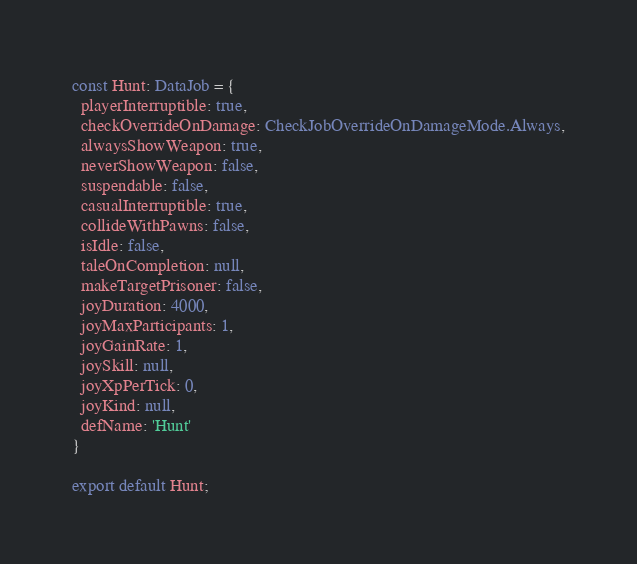<code> <loc_0><loc_0><loc_500><loc_500><_TypeScript_>const Hunt: DataJob = {
  playerInterruptible: true,
  checkOverrideOnDamage: CheckJobOverrideOnDamageMode.Always,
  alwaysShowWeapon: true,
  neverShowWeapon: false,
  suspendable: false,
  casualInterruptible: true,
  collideWithPawns: false,
  isIdle: false,
  taleOnCompletion: null,
  makeTargetPrisoner: false,
  joyDuration: 4000,
  joyMaxParticipants: 1,
  joyGainRate: 1,
  joySkill: null,
  joyXpPerTick: 0,
  joyKind: null,
  defName: 'Hunt'
}

export default Hunt;
</code> 